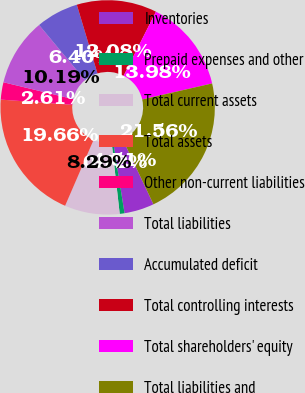<chart> <loc_0><loc_0><loc_500><loc_500><pie_chart><fcel>Inventories<fcel>Prepaid expenses and other<fcel>Total current assets<fcel>Total assets<fcel>Other non-current liabilities<fcel>Total liabilities<fcel>Accumulated deficit<fcel>Total controlling interests<fcel>Total shareholders' equity<fcel>Total liabilities and<nl><fcel>4.51%<fcel>0.72%<fcel>8.29%<fcel>19.66%<fcel>2.61%<fcel>10.19%<fcel>6.4%<fcel>12.08%<fcel>13.98%<fcel>21.56%<nl></chart> 